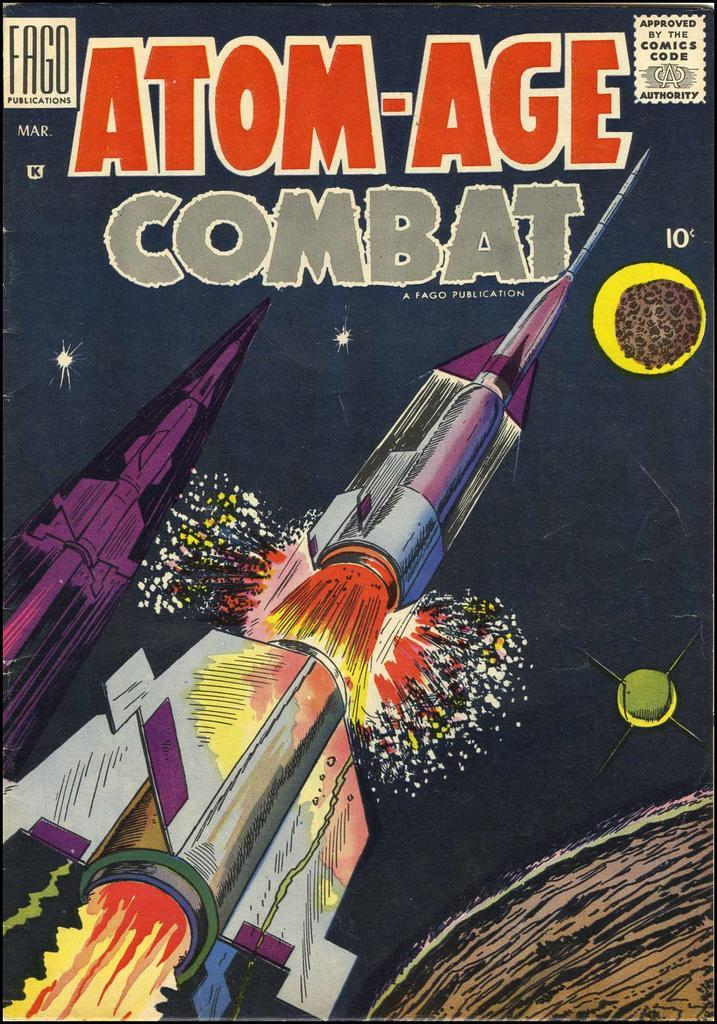<image>
Create a compact narrative representing the image presented. Atom-Age Combat, a comic book sits on display. 